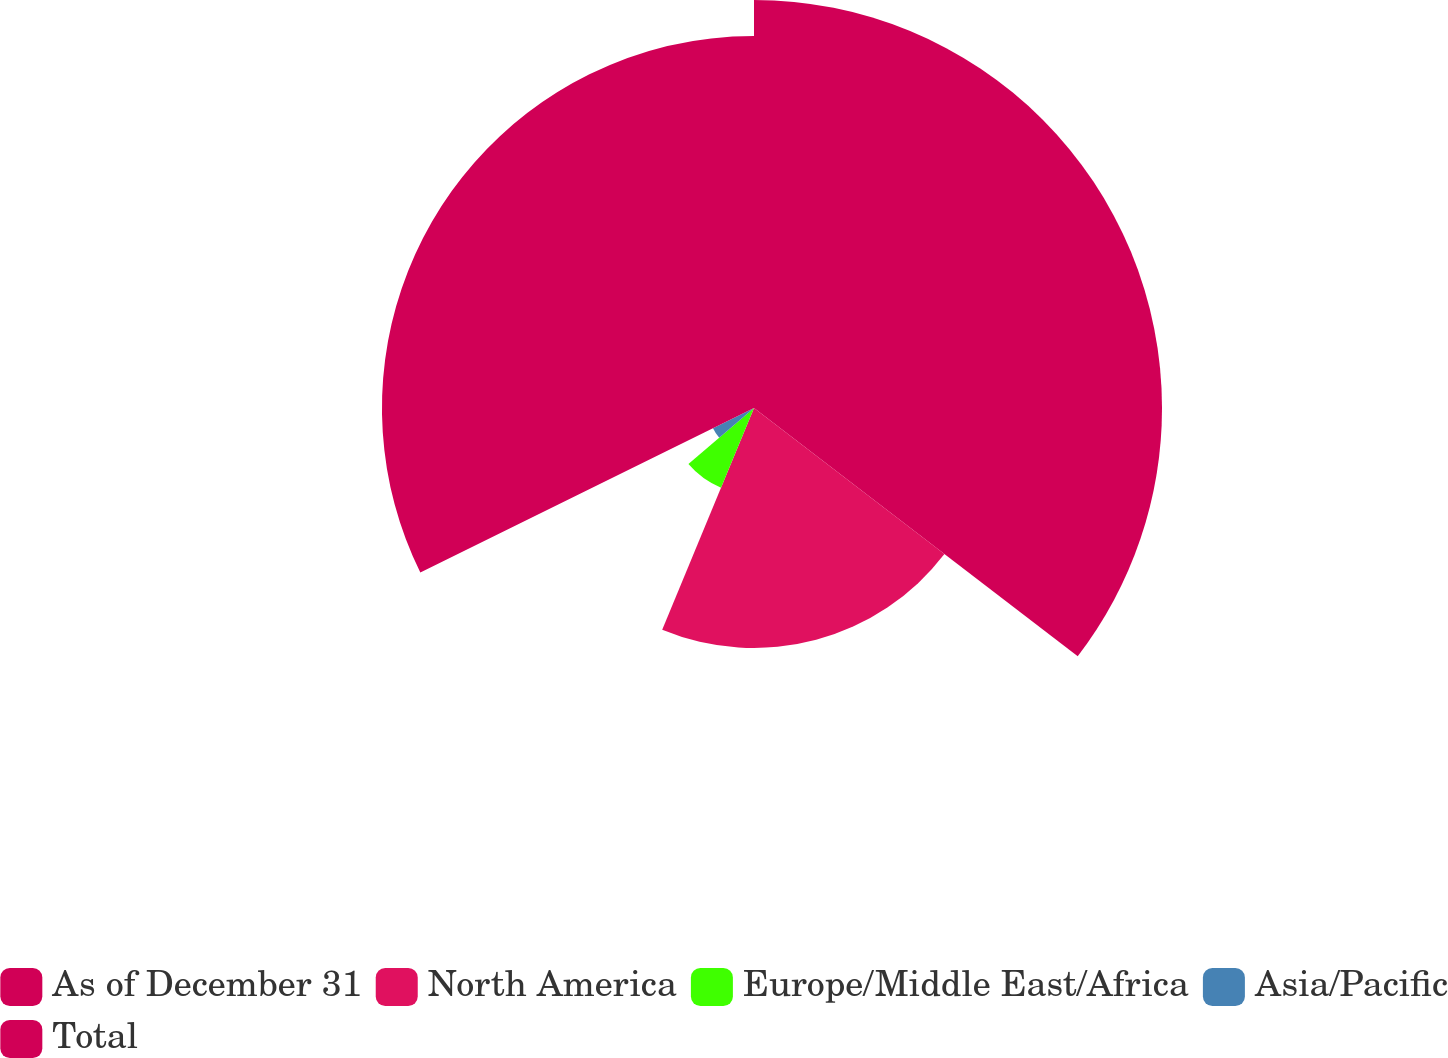Convert chart to OTSL. <chart><loc_0><loc_0><loc_500><loc_500><pie_chart><fcel>As of December 31<fcel>North America<fcel>Europe/Middle East/Africa<fcel>Asia/Pacific<fcel>Total<nl><fcel>35.41%<fcel>20.83%<fcel>7.49%<fcel>3.97%<fcel>32.29%<nl></chart> 